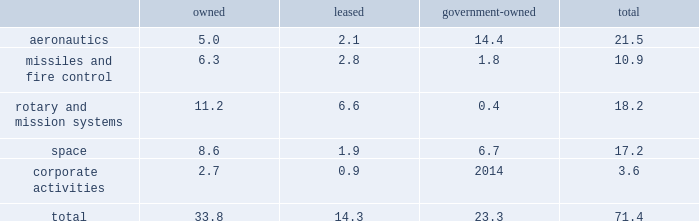Item 2 .
Properties at december 31 , 2017 , we owned or leased building space ( including offices , manufacturing plants , warehouses , service centers , laboratories and other facilities ) at approximately 375 locations primarily in the u.s .
Additionally , we manage or occupy approximately 15 government-owned facilities under lease and other arrangements .
At december 31 , 2017 , we had significant operations in the following locations : 2022 aeronautics - palmdale , california ; marietta , georgia ; greenville , south carolina ; and fort worth , texas .
2022 missiles and fire control - camdenarkansas ; ocala and orlando , florida ; lexington , kentucky ; and grand prairie , texas .
2022 rotary andmission systems - colorado springs , colorado ; shelton and stratford , connecticut ; orlando and jupiter , florida ; moorestown/mt .
Laurel , new jersey ; owego and syracuse , new york ; manassas , virginia ; and mielec , poland .
2022 space - sunnyvale , california ; denver , colorado ; valley forge , pennsylvania ; and reading , england .
2022 corporate activities - bethesda , maryland .
The following is a summary of our square feet of floor space by business segment at december 31 , 2017 ( in millions ) : owned leased government- owned total .
We believe our facilities are in good condition and adequate for their current use.wemay improve , replace or reduce facilities as considered appropriate to meet the needs of our operations .
Item 3 .
Legal proceedings we are a party to or have property subject to litigation and other proceedings that arise in the ordinary course of our business , including matters arising under provisions relating to the protection of the environment and are subject to contingencies related to certain businesses we previously owned .
These types of matters could result in fines , penalties , compensatory or treble damages or non-monetary sanctions or relief .
We believe the probability is remote that the outcome of each of these matters will have a material adverse effect on the corporation as a whole , notwithstanding that the unfavorable resolution of any matter may have a material effect on our net earnings in any particular interim reporting period .
We cannot predict the outcome of legal or other proceedings with certainty .
These matters include the proceedings summarized in 201cnote 14 2013 legal proceedings , commitments and contingencies 201d included in our notes to consolidated financial statements .
We are subject to federal , state , local and foreign requirements for protection of the environment , including those for discharge ofhazardousmaterials and remediationof contaminated sites.due inpart to thecomplexity andpervasivenessof these requirements , we are a party to or have property subject to various lawsuits , proceedings and remediation obligations .
The extent of our financial exposure cannot in all cases be reasonably estimated at this time .
For information regarding these matters , including current estimates of the amounts that we believe are required for remediation or clean-up to the extent estimable , see 201ccriticalaccounting policies - environmental matters 201d in management 2019s discussion and analysis of financial condition and results of operations and 201cnote 14 2013 legal proceedings , commitments andcontingencies 201d included in ournotes to consolidated financial statements .
As a u.s .
Government contractor , we are subject to various audits and investigations by the u.s .
Government to determine whetherouroperations arebeingconducted in accordancewith applicable regulatory requirements.u.s.government investigations of us , whether relating to government contracts or conducted for other reasons , could result in administrative , civil , or criminal liabilities , including repayments , fines or penalties being imposed upon us , suspension , proposed debarment , debarment from eligibility for future u.s .
Government contracting , or suspension of export privileges .
Suspension or debarment could have a material adverse effect on us because of our dependence on contracts with the u.s .
Government .
U.s .
Government investigations often take years to complete and many result in no adverse action against us .
We also provide products and services to customers outside of the u.s. , which are subject to u.s .
And foreign laws and regulations and foreign procurement policies and practices .
Our compliance with local regulations or applicable u.s .
Government regulations also may be audited or investigated .
Item 4 .
Mine safety disclosures not applicable. .
What percentage of square feet of floor space by business segment at december 31 , 2017 are in the missiles and fire control segment? 
Computations: (10.9 / 71.4)
Answer: 0.15266. 